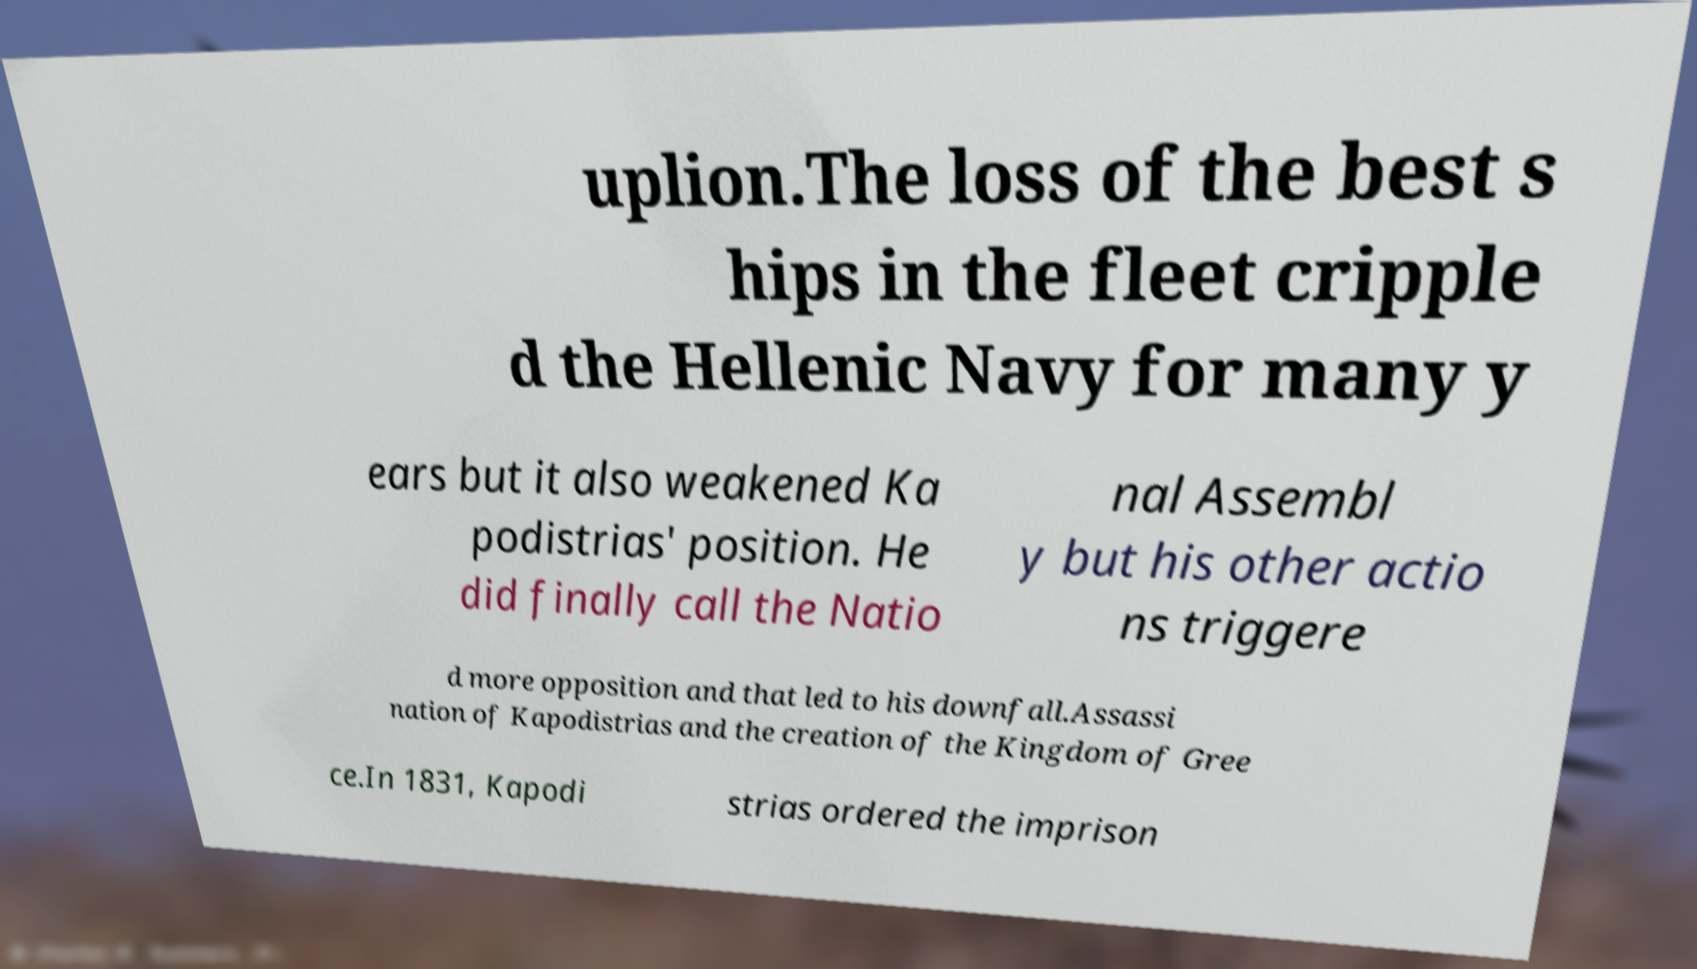Please read and relay the text visible in this image. What does it say? uplion.The loss of the best s hips in the fleet cripple d the Hellenic Navy for many y ears but it also weakened Ka podistrias' position. He did finally call the Natio nal Assembl y but his other actio ns triggere d more opposition and that led to his downfall.Assassi nation of Kapodistrias and the creation of the Kingdom of Gree ce.In 1831, Kapodi strias ordered the imprison 